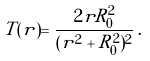<formula> <loc_0><loc_0><loc_500><loc_500>T ( r ) = \frac { 2 r R _ { 0 } ^ { 2 } } { ( r ^ { 2 } + R _ { 0 } ^ { 2 } ) ^ { 2 } } \, .</formula> 